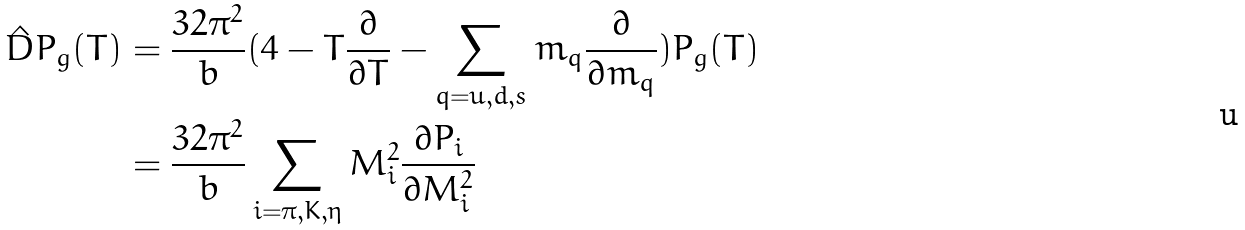<formula> <loc_0><loc_0><loc_500><loc_500>\hat { D } P _ { g } ( T ) & = \frac { 3 2 \pi ^ { 2 } } { b } ( 4 - T \frac { \partial } { \partial T } - \sum _ { q = u , d , s } m _ { q } \frac { \partial } { \partial m _ { q } } ) P _ { g } ( T ) \\ & = \frac { 3 2 \pi ^ { 2 } } { b } \sum _ { i = \pi , K , \eta } M _ { i } ^ { 2 } \frac { \partial P _ { i } } { \partial M _ { i } ^ { 2 } }</formula> 